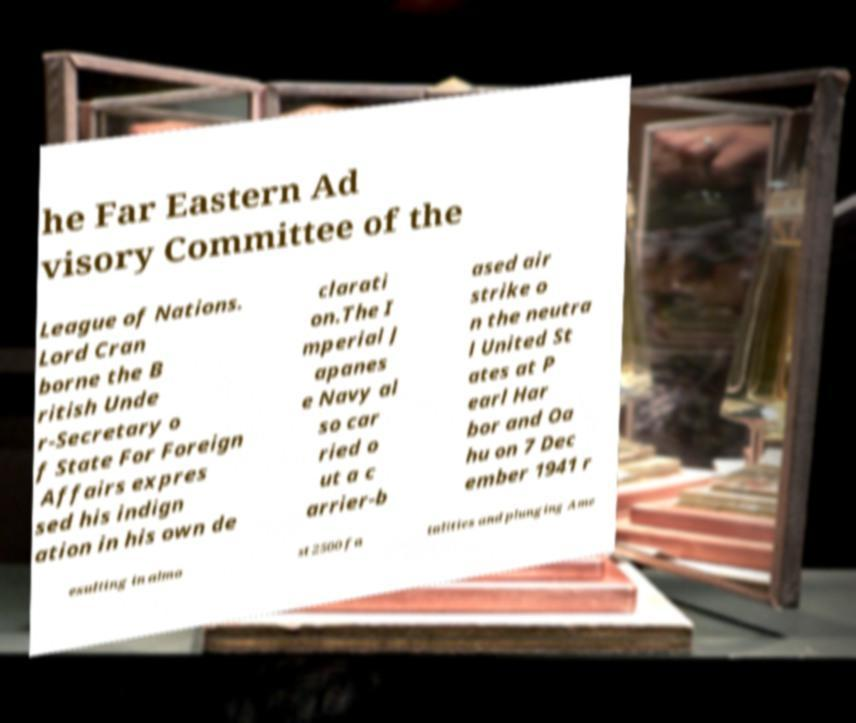Could you assist in decoding the text presented in this image and type it out clearly? he Far Eastern Ad visory Committee of the League of Nations. Lord Cran borne the B ritish Unde r-Secretary o f State For Foreign Affairs expres sed his indign ation in his own de clarati on.The I mperial J apanes e Navy al so car ried o ut a c arrier-b ased air strike o n the neutra l United St ates at P earl Har bor and Oa hu on 7 Dec ember 1941 r esulting in almo st 2500 fa talities and plunging Ame 